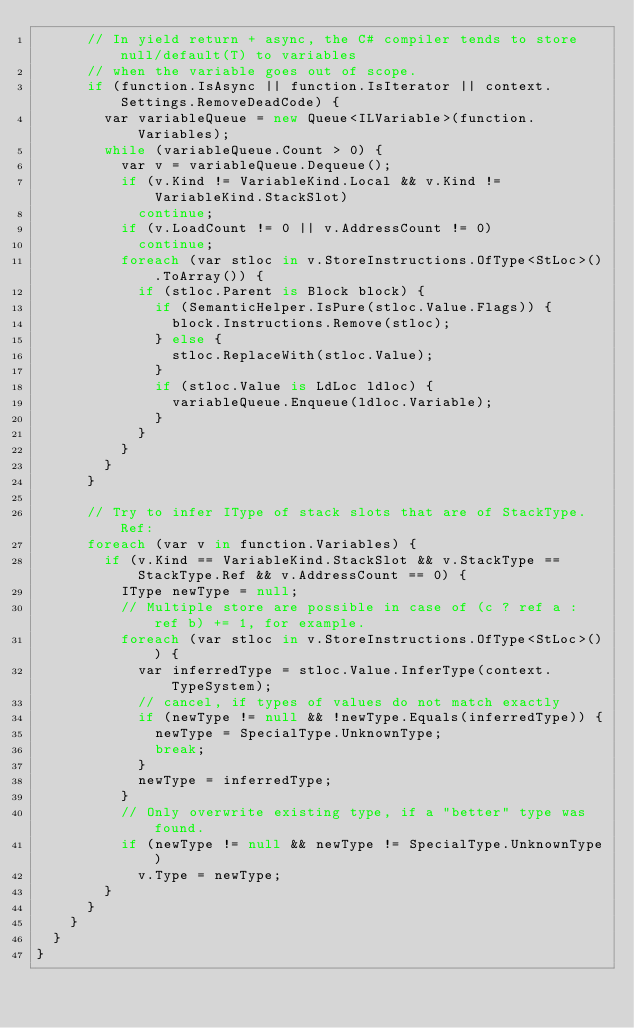<code> <loc_0><loc_0><loc_500><loc_500><_C#_>			// In yield return + async, the C# compiler tends to store null/default(T) to variables
			// when the variable goes out of scope.
			if (function.IsAsync || function.IsIterator || context.Settings.RemoveDeadCode) {
				var variableQueue = new Queue<ILVariable>(function.Variables);
				while (variableQueue.Count > 0) {
					var v = variableQueue.Dequeue();
					if (v.Kind != VariableKind.Local && v.Kind != VariableKind.StackSlot)
						continue;
					if (v.LoadCount != 0 || v.AddressCount != 0)
						continue;
					foreach (var stloc in v.StoreInstructions.OfType<StLoc>().ToArray()) {
						if (stloc.Parent is Block block) {
							if (SemanticHelper.IsPure(stloc.Value.Flags)) {
								block.Instructions.Remove(stloc);
							} else {
								stloc.ReplaceWith(stloc.Value);
							}
							if (stloc.Value is LdLoc ldloc) {
								variableQueue.Enqueue(ldloc.Variable);
							}
						}
					}
				}
			}

			// Try to infer IType of stack slots that are of StackType.Ref:
			foreach (var v in function.Variables) {
				if (v.Kind == VariableKind.StackSlot && v.StackType == StackType.Ref && v.AddressCount == 0) {
					IType newType = null;
					// Multiple store are possible in case of (c ? ref a : ref b) += 1, for example.
					foreach (var stloc in v.StoreInstructions.OfType<StLoc>()) {
						var inferredType = stloc.Value.InferType(context.TypeSystem);
						// cancel, if types of values do not match exactly
						if (newType != null && !newType.Equals(inferredType)) {
							newType = SpecialType.UnknownType;
							break;
						}
						newType = inferredType;
					}
					// Only overwrite existing type, if a "better" type was found.
					if (newType != null && newType != SpecialType.UnknownType)
						v.Type = newType;
				}
			}
		}
	}
}
</code> 